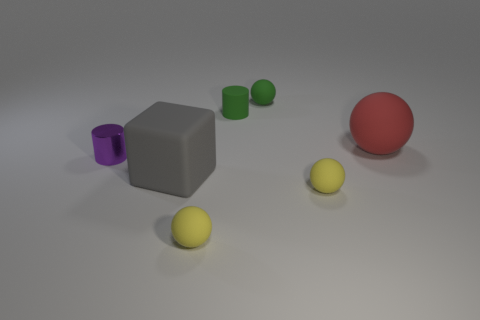Subtract all purple blocks. How many yellow balls are left? 2 Subtract all small green rubber spheres. How many spheres are left? 3 Subtract all brown spheres. Subtract all cyan cylinders. How many spheres are left? 4 Add 3 big spheres. How many objects exist? 10 Subtract all tiny yellow rubber objects. Subtract all small rubber cylinders. How many objects are left? 4 Add 6 small green matte cylinders. How many small green matte cylinders are left? 7 Add 2 green rubber cylinders. How many green rubber cylinders exist? 3 Subtract 0 blue spheres. How many objects are left? 7 Subtract all balls. How many objects are left? 3 